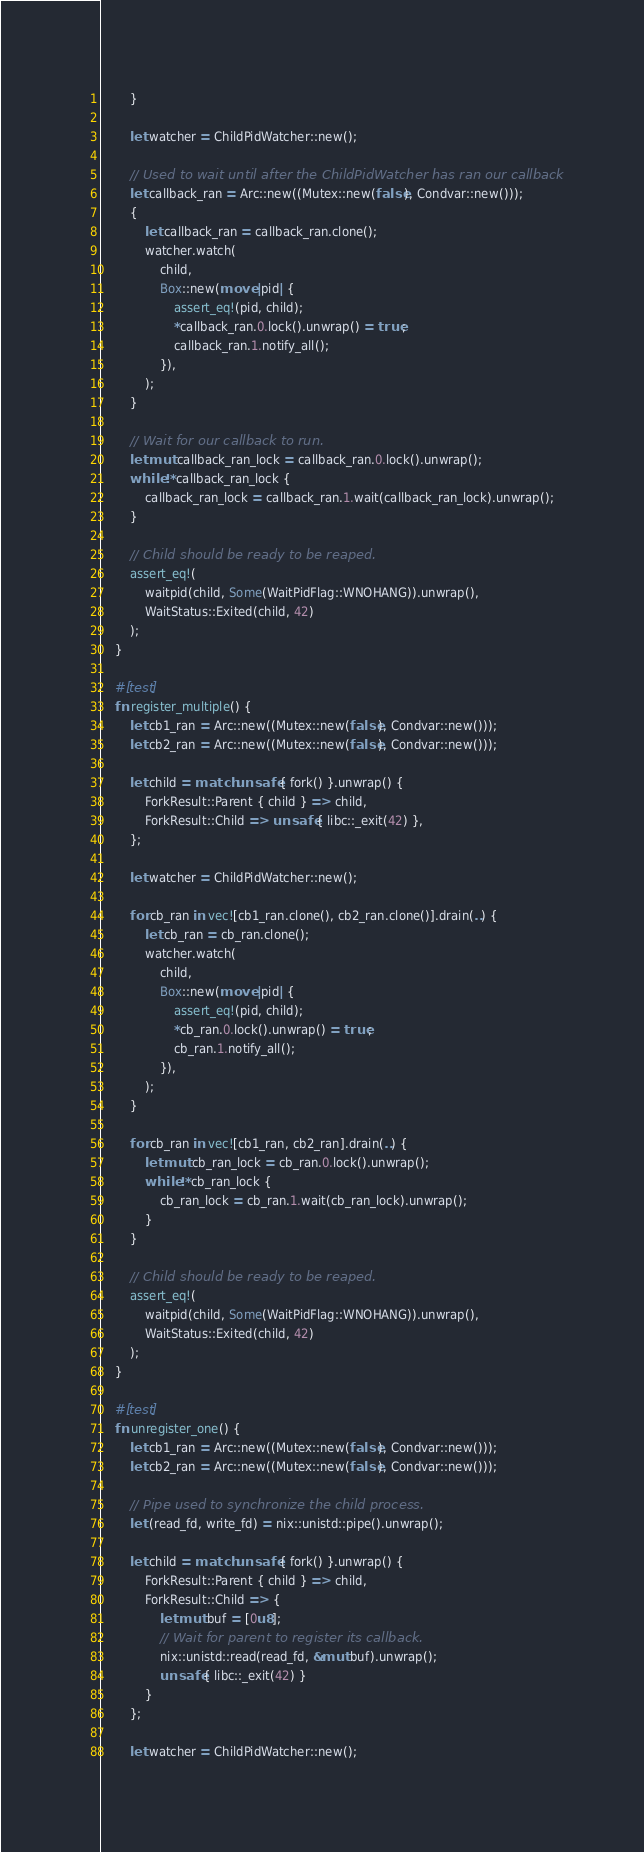Convert code to text. <code><loc_0><loc_0><loc_500><loc_500><_Rust_>        }

        let watcher = ChildPidWatcher::new();

        // Used to wait until after the ChildPidWatcher has ran our callback
        let callback_ran = Arc::new((Mutex::new(false), Condvar::new()));
        {
            let callback_ran = callback_ran.clone();
            watcher.watch(
                child,
                Box::new(move |pid| {
                    assert_eq!(pid, child);
                    *callback_ran.0.lock().unwrap() = true;
                    callback_ran.1.notify_all();
                }),
            );
        }

        // Wait for our callback to run.
        let mut callback_ran_lock = callback_ran.0.lock().unwrap();
        while !*callback_ran_lock {
            callback_ran_lock = callback_ran.1.wait(callback_ran_lock).unwrap();
        }

        // Child should be ready to be reaped.
        assert_eq!(
            waitpid(child, Some(WaitPidFlag::WNOHANG)).unwrap(),
            WaitStatus::Exited(child, 42)
        );
    }

    #[test]
    fn register_multiple() {
        let cb1_ran = Arc::new((Mutex::new(false), Condvar::new()));
        let cb2_ran = Arc::new((Mutex::new(false), Condvar::new()));

        let child = match unsafe { fork() }.unwrap() {
            ForkResult::Parent { child } => child,
            ForkResult::Child => unsafe { libc::_exit(42) },
        };

        let watcher = ChildPidWatcher::new();

        for cb_ran in vec![cb1_ran.clone(), cb2_ran.clone()].drain(..) {
            let cb_ran = cb_ran.clone();
            watcher.watch(
                child,
                Box::new(move |pid| {
                    assert_eq!(pid, child);
                    *cb_ran.0.lock().unwrap() = true;
                    cb_ran.1.notify_all();
                }),
            );
        }

        for cb_ran in vec![cb1_ran, cb2_ran].drain(..) {
            let mut cb_ran_lock = cb_ran.0.lock().unwrap();
            while !*cb_ran_lock {
                cb_ran_lock = cb_ran.1.wait(cb_ran_lock).unwrap();
            }
        }

        // Child should be ready to be reaped.
        assert_eq!(
            waitpid(child, Some(WaitPidFlag::WNOHANG)).unwrap(),
            WaitStatus::Exited(child, 42)
        );
    }

    #[test]
    fn unregister_one() {
        let cb1_ran = Arc::new((Mutex::new(false), Condvar::new()));
        let cb2_ran = Arc::new((Mutex::new(false), Condvar::new()));

        // Pipe used to synchronize the child process.
        let (read_fd, write_fd) = nix::unistd::pipe().unwrap();

        let child = match unsafe { fork() }.unwrap() {
            ForkResult::Parent { child } => child,
            ForkResult::Child => {
                let mut buf = [0u8];
                // Wait for parent to register its callback.
                nix::unistd::read(read_fd, &mut buf).unwrap();
                unsafe { libc::_exit(42) }
            }
        };

        let watcher = ChildPidWatcher::new();
</code> 